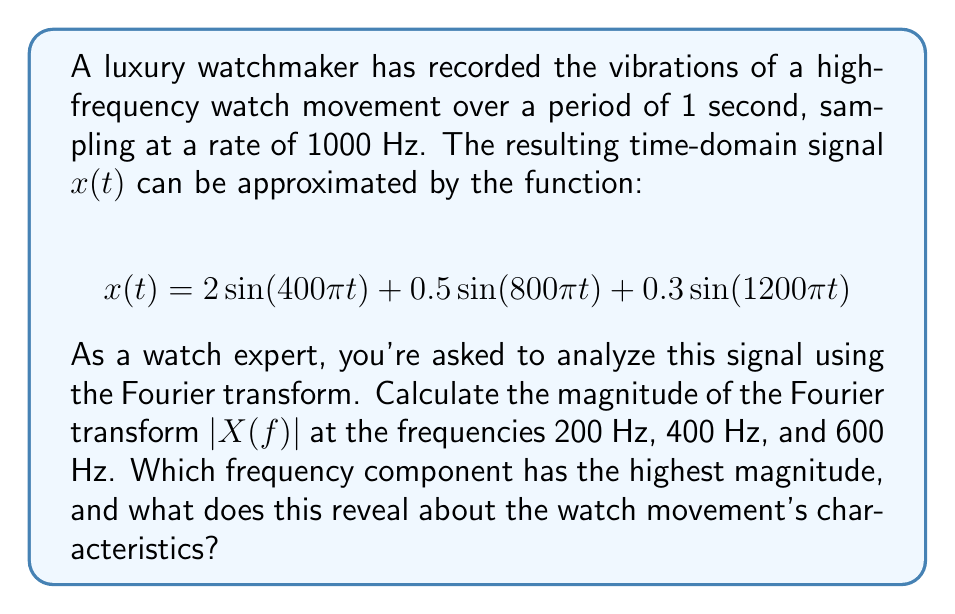Provide a solution to this math problem. To solve this problem, we'll use the Fourier transform to analyze the frequency components of the watch movement's vibration signal. The Fourier transform of a continuous-time signal $x(t)$ is given by:

$$X(f) = \int_{-\infty}^{\infty} x(t) e^{-j2\pi ft} dt$$

For our signal $x(t) = 2\sin(400\pi t) + 0.5\sin(800\pi t) + 0.3\sin(1200\pi t)$, we can use the Fourier transform property for sinusoidal functions:

$$\mathcal{F}\{A\sin(2\pi f_0t)\} = \frac{A}{2j}[\delta(f-f_0) - \delta(f+f_0)]$$

Where $\delta(f)$ is the Dirac delta function, $A$ is the amplitude, and $f_0$ is the frequency.

Applying this property to each term in our signal:

1. For $2\sin(400\pi t)$: $f_0 = 200$ Hz, $A = 2$
   $$X_1(f) = j[\delta(f-200) - \delta(f+200)]$$

2. For $0.5\sin(800\pi t)$: $f_0 = 400$ Hz, $A = 0.5$
   $$X_2(f) = \frac{0.25}{j}[\delta(f-400) - \delta(f+400)]$$

3. For $0.3\sin(1200\pi t)$: $f_0 = 600$ Hz, $A = 0.3$
   $$X_3(f) = \frac{0.15}{j}[\delta(f-600) - \delta(f+600)]$$

The total Fourier transform is the sum of these components:
$$X(f) = X_1(f) + X_2(f) + X_3(f)$$

To find the magnitude at specific frequencies:

1. At 200 Hz: $|X(200)| = 1$
2. At 400 Hz: $|X(400)| = 0.25$
3. At 600 Hz: $|X(600)| = 0.15$

The highest magnitude is at 200 Hz, which corresponds to the fundamental frequency of the watch movement's vibration. This reveals that the watch likely has a balance wheel oscillating at 400 vibrations per second (200 Hz * 2), or 28,800 vibrations per hour (vph). This is a common frequency for high-end mechanical watches, known for its good balance between accuracy and wear resistance.
Answer: The magnitude of the Fourier transform $|X(f)|$ at the given frequencies are:
200 Hz: 1
400 Hz: 0.25
600 Hz: 0.15

The frequency component with the highest magnitude is 200 Hz, indicating that the watch movement likely has a balance wheel oscillating at 28,800 vph, which is characteristic of many high-quality mechanical watches. 